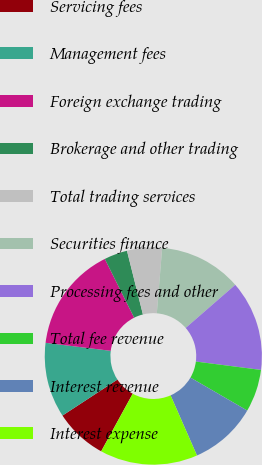Convert chart to OTSL. <chart><loc_0><loc_0><loc_500><loc_500><pie_chart><fcel>Servicing fees<fcel>Management fees<fcel>Foreign exchange trading<fcel>Brokerage and other trading<fcel>Total trading services<fcel>Securities finance<fcel>Processing fees and other<fcel>Total fee revenue<fcel>Interest revenue<fcel>Interest expense<nl><fcel>7.8%<fcel>11.18%<fcel>15.68%<fcel>3.47%<fcel>5.2%<fcel>12.31%<fcel>13.43%<fcel>6.33%<fcel>10.05%<fcel>14.56%<nl></chart> 